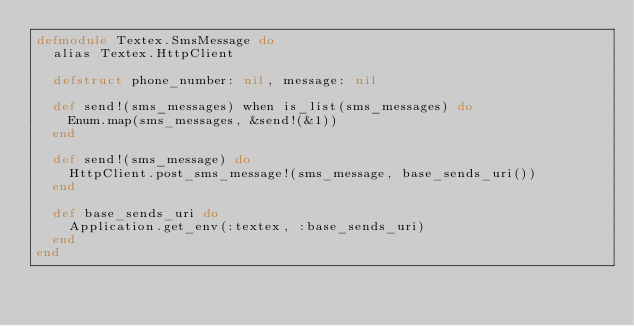Convert code to text. <code><loc_0><loc_0><loc_500><loc_500><_Elixir_>defmodule Textex.SmsMessage do
  alias Textex.HttpClient

  defstruct phone_number: nil, message: nil

  def send!(sms_messages) when is_list(sms_messages) do
    Enum.map(sms_messages, &send!(&1))
  end

  def send!(sms_message) do
    HttpClient.post_sms_message!(sms_message, base_sends_uri())
  end

  def base_sends_uri do
    Application.get_env(:textex, :base_sends_uri)
  end
end
</code> 